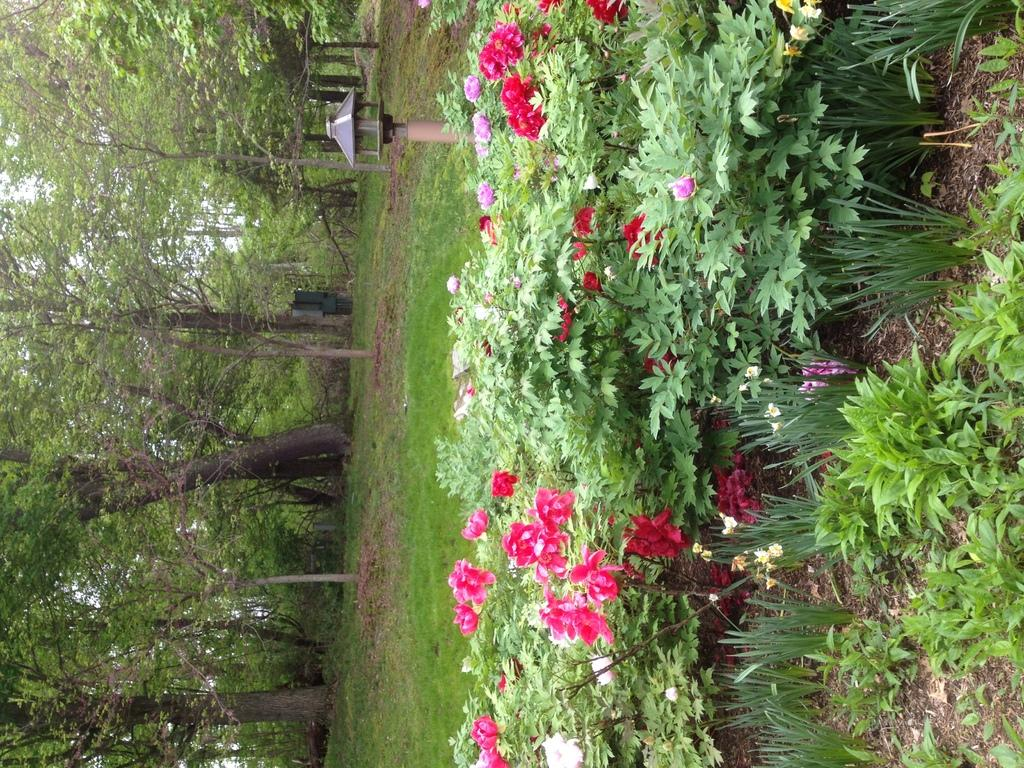What type of plants can be seen in the image? There are flower plants in the image. What is the color of the grass in the image? The grass in the image is green. What other type of vegetation is present in the image? There are trees in the image. Can you hear the whistle of the wind blowing through the trees in the image? There is no sound present in the image, so it is not possible to hear any whistling. 